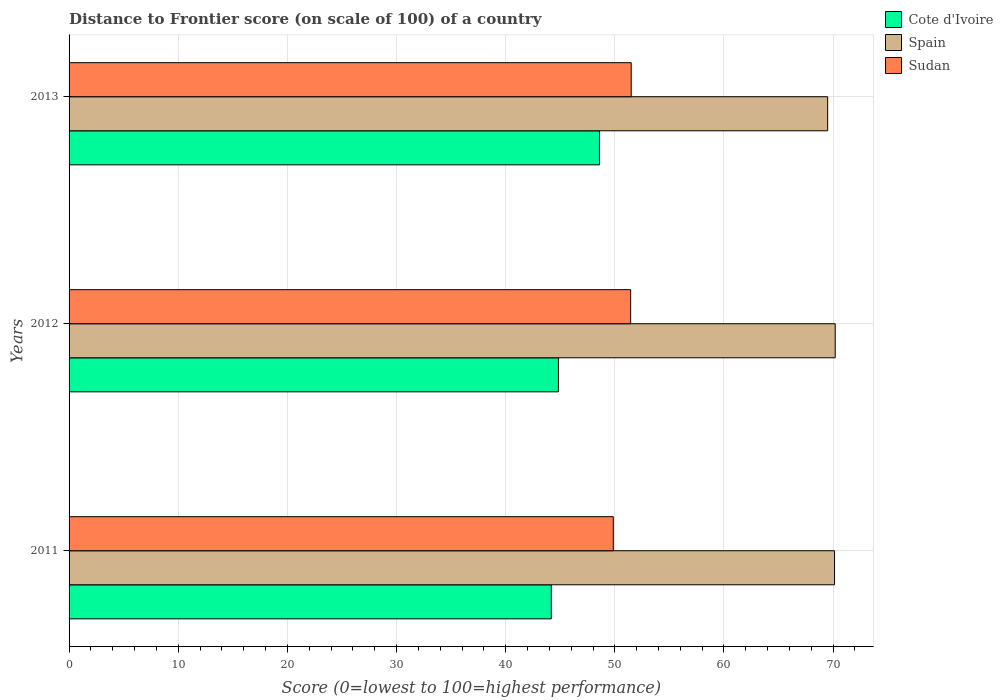Are the number of bars per tick equal to the number of legend labels?
Provide a short and direct response. Yes. Are the number of bars on each tick of the Y-axis equal?
Your answer should be compact. Yes. What is the label of the 2nd group of bars from the top?
Your answer should be very brief. 2012. In how many cases, is the number of bars for a given year not equal to the number of legend labels?
Your answer should be very brief. 0. What is the distance to frontier score of in Sudan in 2013?
Provide a succinct answer. 51.5. Across all years, what is the maximum distance to frontier score of in Spain?
Your answer should be very brief. 70.19. Across all years, what is the minimum distance to frontier score of in Spain?
Make the answer very short. 69.5. In which year was the distance to frontier score of in Cote d'Ivoire maximum?
Your answer should be very brief. 2013. What is the total distance to frontier score of in Sudan in the graph?
Keep it short and to the point. 152.81. What is the difference between the distance to frontier score of in Sudan in 2011 and that in 2013?
Your answer should be very brief. -1.64. What is the difference between the distance to frontier score of in Spain in 2011 and the distance to frontier score of in Sudan in 2013?
Offer a terse response. 18.63. What is the average distance to frontier score of in Cote d'Ivoire per year?
Make the answer very short. 45.87. In how many years, is the distance to frontier score of in Spain greater than 24 ?
Provide a succinct answer. 3. What is the ratio of the distance to frontier score of in Spain in 2011 to that in 2012?
Offer a very short reply. 1. Is the distance to frontier score of in Spain in 2011 less than that in 2013?
Provide a succinct answer. No. Is the difference between the distance to frontier score of in Sudan in 2012 and 2013 greater than the difference between the distance to frontier score of in Spain in 2012 and 2013?
Keep it short and to the point. No. What is the difference between the highest and the second highest distance to frontier score of in Sudan?
Your response must be concise. 0.05. What is the difference between the highest and the lowest distance to frontier score of in Cote d'Ivoire?
Offer a very short reply. 4.41. In how many years, is the distance to frontier score of in Sudan greater than the average distance to frontier score of in Sudan taken over all years?
Give a very brief answer. 2. Is the sum of the distance to frontier score of in Cote d'Ivoire in 2012 and 2013 greater than the maximum distance to frontier score of in Sudan across all years?
Offer a terse response. Yes. What does the 1st bar from the top in 2011 represents?
Your answer should be compact. Sudan. What does the 1st bar from the bottom in 2012 represents?
Keep it short and to the point. Cote d'Ivoire. Is it the case that in every year, the sum of the distance to frontier score of in Cote d'Ivoire and distance to frontier score of in Spain is greater than the distance to frontier score of in Sudan?
Offer a very short reply. Yes. How many bars are there?
Keep it short and to the point. 9. Are all the bars in the graph horizontal?
Offer a terse response. Yes. Does the graph contain any zero values?
Provide a succinct answer. No. Does the graph contain grids?
Your response must be concise. Yes. What is the title of the graph?
Your answer should be compact. Distance to Frontier score (on scale of 100) of a country. Does "Kenya" appear as one of the legend labels in the graph?
Provide a succinct answer. No. What is the label or title of the X-axis?
Your answer should be compact. Score (0=lowest to 100=highest performance). What is the label or title of the Y-axis?
Provide a succinct answer. Years. What is the Score (0=lowest to 100=highest performance) in Cote d'Ivoire in 2011?
Provide a short and direct response. 44.18. What is the Score (0=lowest to 100=highest performance) in Spain in 2011?
Make the answer very short. 70.13. What is the Score (0=lowest to 100=highest performance) in Sudan in 2011?
Offer a very short reply. 49.86. What is the Score (0=lowest to 100=highest performance) in Cote d'Ivoire in 2012?
Offer a terse response. 44.83. What is the Score (0=lowest to 100=highest performance) of Spain in 2012?
Ensure brevity in your answer.  70.19. What is the Score (0=lowest to 100=highest performance) of Sudan in 2012?
Your response must be concise. 51.45. What is the Score (0=lowest to 100=highest performance) in Cote d'Ivoire in 2013?
Your answer should be very brief. 48.59. What is the Score (0=lowest to 100=highest performance) of Spain in 2013?
Offer a terse response. 69.5. What is the Score (0=lowest to 100=highest performance) of Sudan in 2013?
Provide a succinct answer. 51.5. Across all years, what is the maximum Score (0=lowest to 100=highest performance) in Cote d'Ivoire?
Ensure brevity in your answer.  48.59. Across all years, what is the maximum Score (0=lowest to 100=highest performance) in Spain?
Your answer should be very brief. 70.19. Across all years, what is the maximum Score (0=lowest to 100=highest performance) of Sudan?
Your answer should be very brief. 51.5. Across all years, what is the minimum Score (0=lowest to 100=highest performance) of Cote d'Ivoire?
Give a very brief answer. 44.18. Across all years, what is the minimum Score (0=lowest to 100=highest performance) of Spain?
Your response must be concise. 69.5. Across all years, what is the minimum Score (0=lowest to 100=highest performance) of Sudan?
Offer a terse response. 49.86. What is the total Score (0=lowest to 100=highest performance) of Cote d'Ivoire in the graph?
Your response must be concise. 137.6. What is the total Score (0=lowest to 100=highest performance) of Spain in the graph?
Offer a terse response. 209.82. What is the total Score (0=lowest to 100=highest performance) of Sudan in the graph?
Your answer should be compact. 152.81. What is the difference between the Score (0=lowest to 100=highest performance) in Cote d'Ivoire in 2011 and that in 2012?
Make the answer very short. -0.65. What is the difference between the Score (0=lowest to 100=highest performance) in Spain in 2011 and that in 2012?
Provide a short and direct response. -0.06. What is the difference between the Score (0=lowest to 100=highest performance) in Sudan in 2011 and that in 2012?
Offer a terse response. -1.59. What is the difference between the Score (0=lowest to 100=highest performance) in Cote d'Ivoire in 2011 and that in 2013?
Provide a short and direct response. -4.41. What is the difference between the Score (0=lowest to 100=highest performance) of Spain in 2011 and that in 2013?
Offer a terse response. 0.63. What is the difference between the Score (0=lowest to 100=highest performance) of Sudan in 2011 and that in 2013?
Make the answer very short. -1.64. What is the difference between the Score (0=lowest to 100=highest performance) in Cote d'Ivoire in 2012 and that in 2013?
Your response must be concise. -3.76. What is the difference between the Score (0=lowest to 100=highest performance) of Spain in 2012 and that in 2013?
Your answer should be compact. 0.69. What is the difference between the Score (0=lowest to 100=highest performance) in Sudan in 2012 and that in 2013?
Offer a terse response. -0.05. What is the difference between the Score (0=lowest to 100=highest performance) of Cote d'Ivoire in 2011 and the Score (0=lowest to 100=highest performance) of Spain in 2012?
Ensure brevity in your answer.  -26.01. What is the difference between the Score (0=lowest to 100=highest performance) of Cote d'Ivoire in 2011 and the Score (0=lowest to 100=highest performance) of Sudan in 2012?
Offer a terse response. -7.27. What is the difference between the Score (0=lowest to 100=highest performance) in Spain in 2011 and the Score (0=lowest to 100=highest performance) in Sudan in 2012?
Keep it short and to the point. 18.68. What is the difference between the Score (0=lowest to 100=highest performance) of Cote d'Ivoire in 2011 and the Score (0=lowest to 100=highest performance) of Spain in 2013?
Keep it short and to the point. -25.32. What is the difference between the Score (0=lowest to 100=highest performance) of Cote d'Ivoire in 2011 and the Score (0=lowest to 100=highest performance) of Sudan in 2013?
Provide a short and direct response. -7.32. What is the difference between the Score (0=lowest to 100=highest performance) of Spain in 2011 and the Score (0=lowest to 100=highest performance) of Sudan in 2013?
Offer a very short reply. 18.63. What is the difference between the Score (0=lowest to 100=highest performance) in Cote d'Ivoire in 2012 and the Score (0=lowest to 100=highest performance) in Spain in 2013?
Make the answer very short. -24.67. What is the difference between the Score (0=lowest to 100=highest performance) in Cote d'Ivoire in 2012 and the Score (0=lowest to 100=highest performance) in Sudan in 2013?
Your response must be concise. -6.67. What is the difference between the Score (0=lowest to 100=highest performance) of Spain in 2012 and the Score (0=lowest to 100=highest performance) of Sudan in 2013?
Provide a short and direct response. 18.69. What is the average Score (0=lowest to 100=highest performance) of Cote d'Ivoire per year?
Your answer should be compact. 45.87. What is the average Score (0=lowest to 100=highest performance) in Spain per year?
Offer a very short reply. 69.94. What is the average Score (0=lowest to 100=highest performance) in Sudan per year?
Keep it short and to the point. 50.94. In the year 2011, what is the difference between the Score (0=lowest to 100=highest performance) of Cote d'Ivoire and Score (0=lowest to 100=highest performance) of Spain?
Ensure brevity in your answer.  -25.95. In the year 2011, what is the difference between the Score (0=lowest to 100=highest performance) of Cote d'Ivoire and Score (0=lowest to 100=highest performance) of Sudan?
Offer a terse response. -5.68. In the year 2011, what is the difference between the Score (0=lowest to 100=highest performance) in Spain and Score (0=lowest to 100=highest performance) in Sudan?
Give a very brief answer. 20.27. In the year 2012, what is the difference between the Score (0=lowest to 100=highest performance) in Cote d'Ivoire and Score (0=lowest to 100=highest performance) in Spain?
Your answer should be compact. -25.36. In the year 2012, what is the difference between the Score (0=lowest to 100=highest performance) of Cote d'Ivoire and Score (0=lowest to 100=highest performance) of Sudan?
Ensure brevity in your answer.  -6.62. In the year 2012, what is the difference between the Score (0=lowest to 100=highest performance) of Spain and Score (0=lowest to 100=highest performance) of Sudan?
Provide a short and direct response. 18.74. In the year 2013, what is the difference between the Score (0=lowest to 100=highest performance) in Cote d'Ivoire and Score (0=lowest to 100=highest performance) in Spain?
Give a very brief answer. -20.91. In the year 2013, what is the difference between the Score (0=lowest to 100=highest performance) of Cote d'Ivoire and Score (0=lowest to 100=highest performance) of Sudan?
Ensure brevity in your answer.  -2.91. What is the ratio of the Score (0=lowest to 100=highest performance) in Cote d'Ivoire in 2011 to that in 2012?
Ensure brevity in your answer.  0.99. What is the ratio of the Score (0=lowest to 100=highest performance) of Spain in 2011 to that in 2012?
Make the answer very short. 1. What is the ratio of the Score (0=lowest to 100=highest performance) of Sudan in 2011 to that in 2012?
Offer a very short reply. 0.97. What is the ratio of the Score (0=lowest to 100=highest performance) of Cote d'Ivoire in 2011 to that in 2013?
Make the answer very short. 0.91. What is the ratio of the Score (0=lowest to 100=highest performance) in Spain in 2011 to that in 2013?
Give a very brief answer. 1.01. What is the ratio of the Score (0=lowest to 100=highest performance) in Sudan in 2011 to that in 2013?
Ensure brevity in your answer.  0.97. What is the ratio of the Score (0=lowest to 100=highest performance) of Cote d'Ivoire in 2012 to that in 2013?
Give a very brief answer. 0.92. What is the ratio of the Score (0=lowest to 100=highest performance) in Spain in 2012 to that in 2013?
Offer a terse response. 1.01. What is the difference between the highest and the second highest Score (0=lowest to 100=highest performance) of Cote d'Ivoire?
Ensure brevity in your answer.  3.76. What is the difference between the highest and the lowest Score (0=lowest to 100=highest performance) of Cote d'Ivoire?
Your answer should be compact. 4.41. What is the difference between the highest and the lowest Score (0=lowest to 100=highest performance) of Spain?
Your answer should be very brief. 0.69. What is the difference between the highest and the lowest Score (0=lowest to 100=highest performance) of Sudan?
Give a very brief answer. 1.64. 